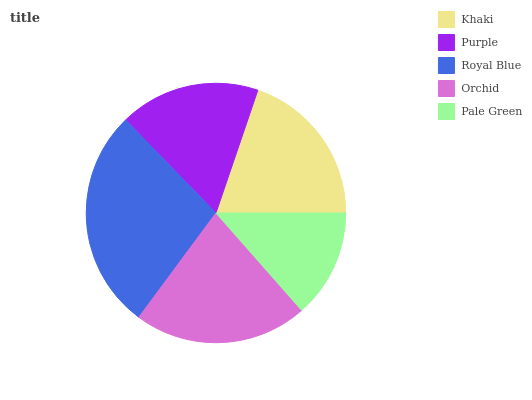Is Pale Green the minimum?
Answer yes or no. Yes. Is Royal Blue the maximum?
Answer yes or no. Yes. Is Purple the minimum?
Answer yes or no. No. Is Purple the maximum?
Answer yes or no. No. Is Khaki greater than Purple?
Answer yes or no. Yes. Is Purple less than Khaki?
Answer yes or no. Yes. Is Purple greater than Khaki?
Answer yes or no. No. Is Khaki less than Purple?
Answer yes or no. No. Is Khaki the high median?
Answer yes or no. Yes. Is Khaki the low median?
Answer yes or no. Yes. Is Royal Blue the high median?
Answer yes or no. No. Is Royal Blue the low median?
Answer yes or no. No. 